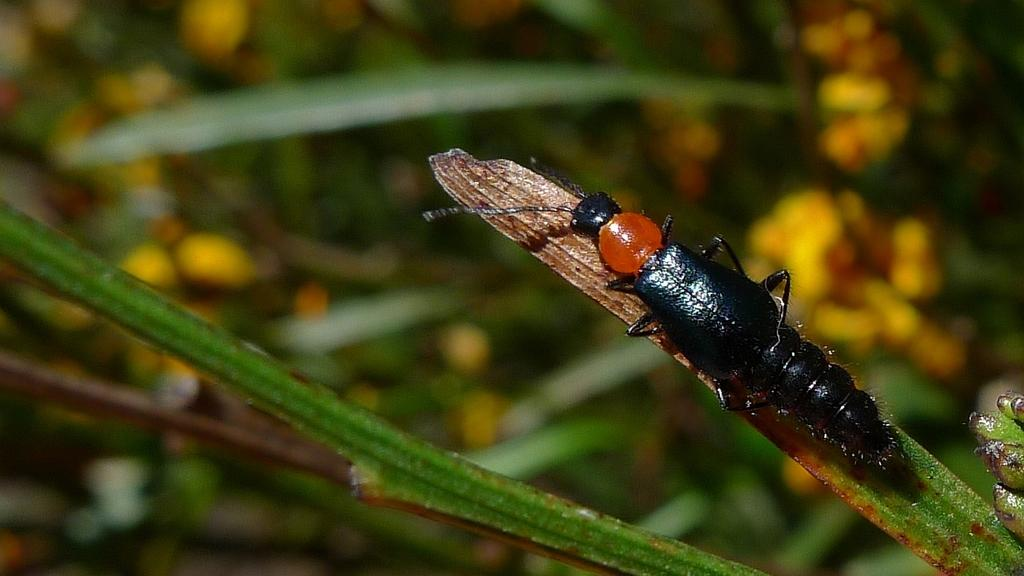What is the main subject of the image? There is an insect on a leaf in the image. What can be seen in the background of the image? There are leaves and flowers visible in the background of the image. How is the background of the image depicted? The background appears blurry. What country is the insect from in the image? The image does not provide information about the insect's country of origin. What fact can be learned about the insect from the image? The image shows the insect on a leaf, but it does not provide any specific facts about the insect. 